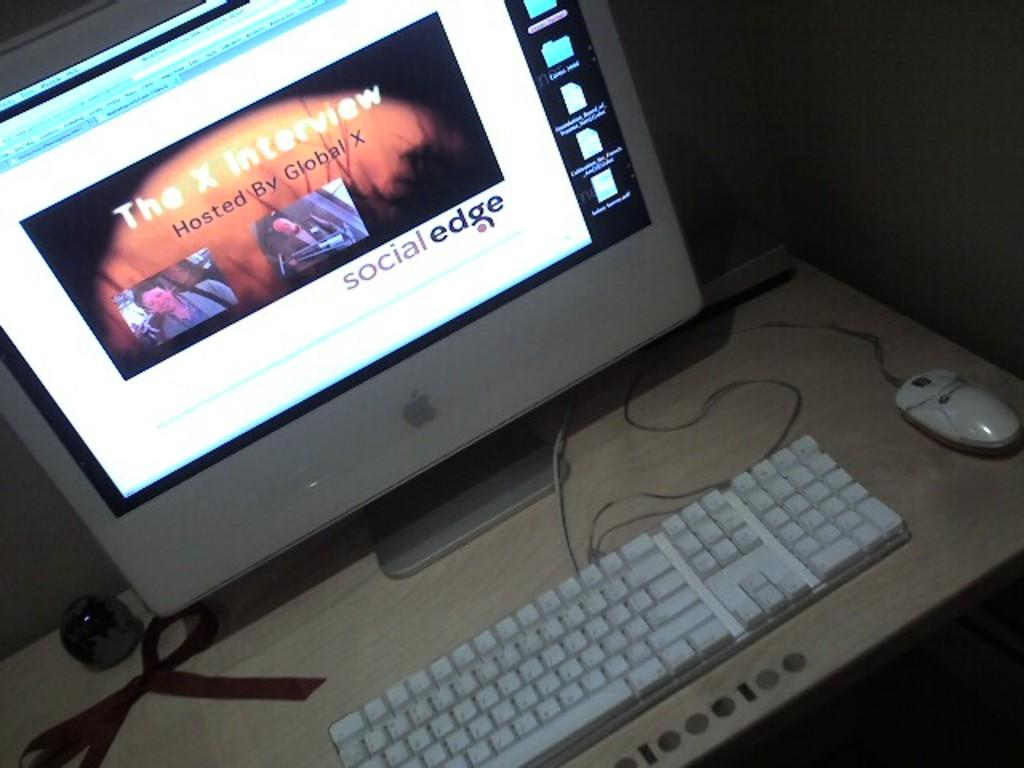Provide a one-sentence caption for the provided image. The website is titled Social Edge with a white background. 